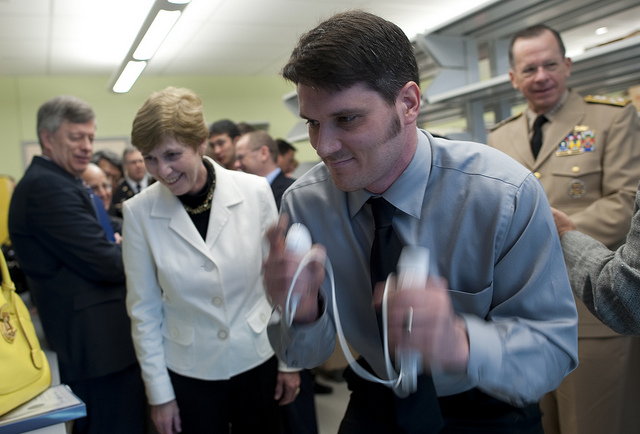What is the person in the foreground doing? The person in the foreground seems to be in motion, as if demonstrating or performing a task, possibly a scientific demonstration or experiment, given the indoor setting and the audience's attention. 